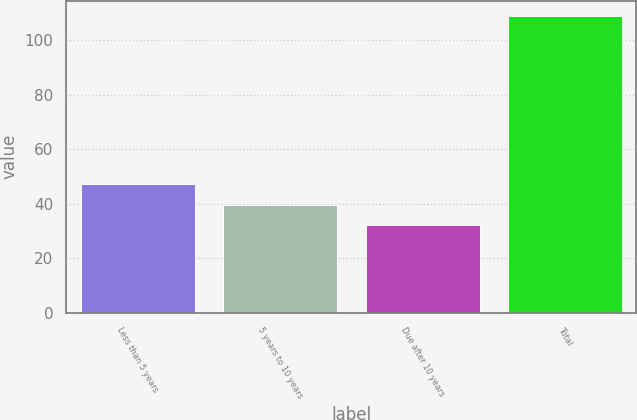Convert chart to OTSL. <chart><loc_0><loc_0><loc_500><loc_500><bar_chart><fcel>Less than 5 years<fcel>5 years to 10 years<fcel>Due after 10 years<fcel>Total<nl><fcel>47.4<fcel>39.7<fcel>32<fcel>109<nl></chart> 